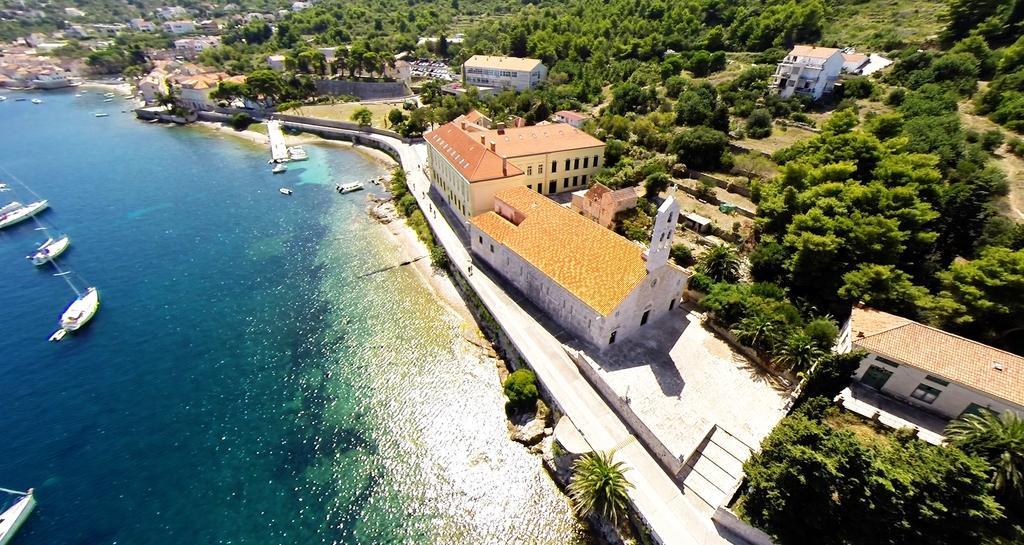Could you give a brief overview of what you see in this image? In this image I can see water on the left side and on it I can see number of boats. On the right side of this image I can see number of trees and number of buildings. 